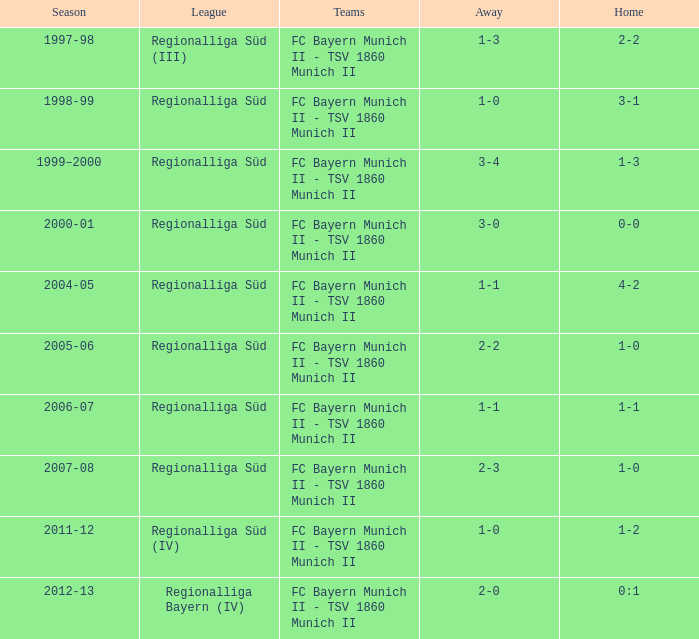What league has a 3-1 home? Regionalliga Süd. 